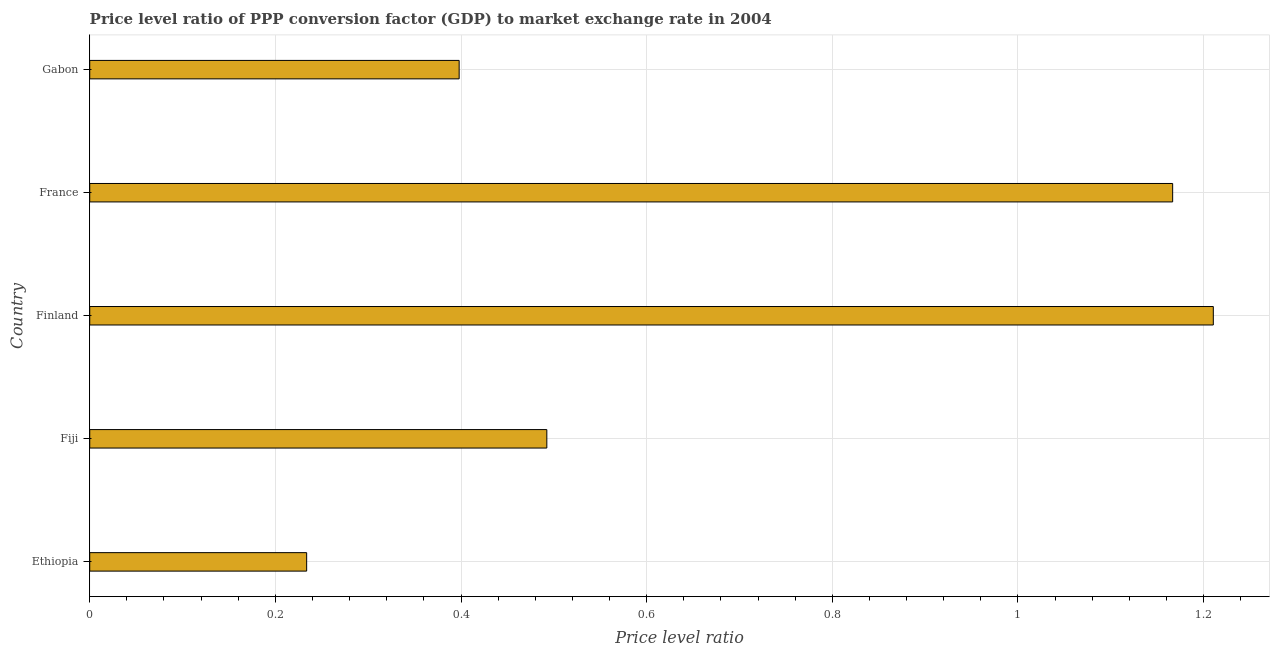Does the graph contain any zero values?
Make the answer very short. No. Does the graph contain grids?
Keep it short and to the point. Yes. What is the title of the graph?
Offer a very short reply. Price level ratio of PPP conversion factor (GDP) to market exchange rate in 2004. What is the label or title of the X-axis?
Your answer should be compact. Price level ratio. What is the price level ratio in Finland?
Provide a succinct answer. 1.21. Across all countries, what is the maximum price level ratio?
Give a very brief answer. 1.21. Across all countries, what is the minimum price level ratio?
Your answer should be compact. 0.23. In which country was the price level ratio maximum?
Offer a terse response. Finland. In which country was the price level ratio minimum?
Provide a short and direct response. Ethiopia. What is the sum of the price level ratio?
Offer a very short reply. 3.5. What is the difference between the price level ratio in Finland and Gabon?
Provide a succinct answer. 0.81. What is the median price level ratio?
Offer a terse response. 0.49. What is the ratio of the price level ratio in Ethiopia to that in Fiji?
Your answer should be compact. 0.47. Is the difference between the price level ratio in Fiji and France greater than the difference between any two countries?
Provide a short and direct response. No. What is the difference between the highest and the second highest price level ratio?
Provide a short and direct response. 0.04. What is the difference between the highest and the lowest price level ratio?
Your response must be concise. 0.98. Are all the bars in the graph horizontal?
Ensure brevity in your answer.  Yes. What is the difference between two consecutive major ticks on the X-axis?
Provide a short and direct response. 0.2. What is the Price level ratio of Ethiopia?
Make the answer very short. 0.23. What is the Price level ratio of Fiji?
Provide a short and direct response. 0.49. What is the Price level ratio in Finland?
Provide a short and direct response. 1.21. What is the Price level ratio of France?
Provide a succinct answer. 1.17. What is the Price level ratio in Gabon?
Provide a short and direct response. 0.4. What is the difference between the Price level ratio in Ethiopia and Fiji?
Your response must be concise. -0.26. What is the difference between the Price level ratio in Ethiopia and Finland?
Your answer should be very brief. -0.98. What is the difference between the Price level ratio in Ethiopia and France?
Ensure brevity in your answer.  -0.93. What is the difference between the Price level ratio in Ethiopia and Gabon?
Make the answer very short. -0.16. What is the difference between the Price level ratio in Fiji and Finland?
Ensure brevity in your answer.  -0.72. What is the difference between the Price level ratio in Fiji and France?
Provide a short and direct response. -0.67. What is the difference between the Price level ratio in Fiji and Gabon?
Provide a short and direct response. 0.09. What is the difference between the Price level ratio in Finland and France?
Give a very brief answer. 0.04. What is the difference between the Price level ratio in Finland and Gabon?
Ensure brevity in your answer.  0.81. What is the difference between the Price level ratio in France and Gabon?
Make the answer very short. 0.77. What is the ratio of the Price level ratio in Ethiopia to that in Fiji?
Keep it short and to the point. 0.47. What is the ratio of the Price level ratio in Ethiopia to that in Finland?
Your answer should be compact. 0.19. What is the ratio of the Price level ratio in Ethiopia to that in Gabon?
Offer a terse response. 0.59. What is the ratio of the Price level ratio in Fiji to that in Finland?
Your response must be concise. 0.41. What is the ratio of the Price level ratio in Fiji to that in France?
Your answer should be compact. 0.42. What is the ratio of the Price level ratio in Fiji to that in Gabon?
Make the answer very short. 1.24. What is the ratio of the Price level ratio in Finland to that in France?
Offer a terse response. 1.04. What is the ratio of the Price level ratio in Finland to that in Gabon?
Your answer should be very brief. 3.04. What is the ratio of the Price level ratio in France to that in Gabon?
Keep it short and to the point. 2.93. 